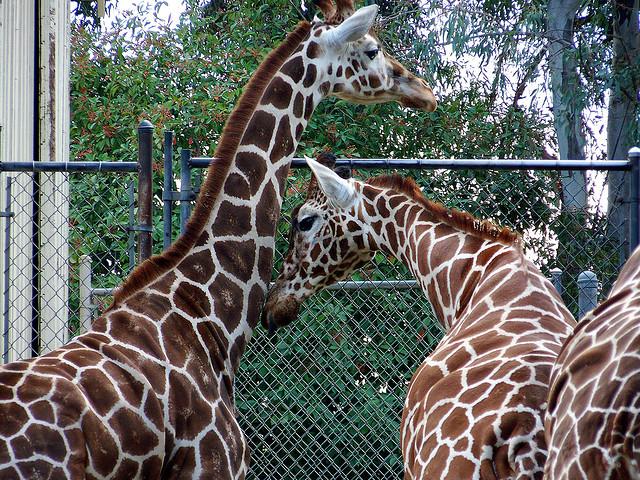Are these animals roaming free?
Give a very brief answer. No. Is the giraffe hungry?
Be succinct. Yes. Are these animals safe?
Keep it brief. Yes. What kind of animal is this?
Concise answer only. Giraffe. 